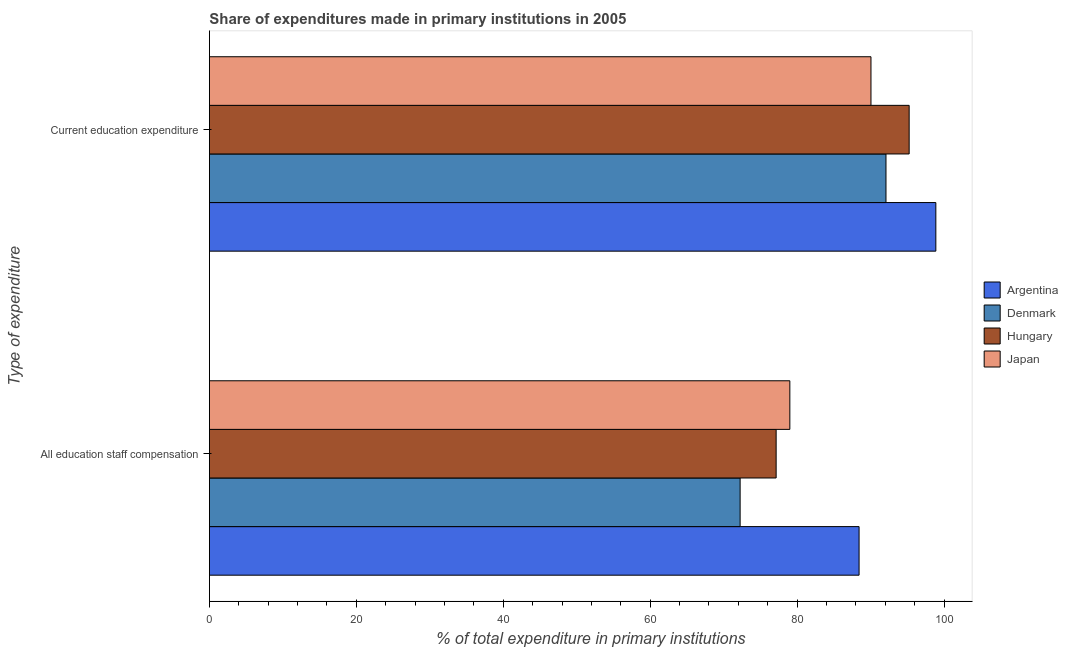How many different coloured bars are there?
Your answer should be very brief. 4. How many groups of bars are there?
Offer a very short reply. 2. Are the number of bars on each tick of the Y-axis equal?
Your answer should be very brief. Yes. How many bars are there on the 2nd tick from the bottom?
Your answer should be compact. 4. What is the label of the 2nd group of bars from the top?
Give a very brief answer. All education staff compensation. What is the expenditure in education in Hungary?
Provide a succinct answer. 95.25. Across all countries, what is the maximum expenditure in staff compensation?
Make the answer very short. 88.43. Across all countries, what is the minimum expenditure in education?
Give a very brief answer. 90.05. What is the total expenditure in education in the graph?
Provide a succinct answer. 376.27. What is the difference between the expenditure in staff compensation in Japan and that in Hungary?
Give a very brief answer. 1.86. What is the difference between the expenditure in staff compensation in Denmark and the expenditure in education in Japan?
Provide a succinct answer. -17.81. What is the average expenditure in education per country?
Offer a terse response. 94.07. What is the difference between the expenditure in education and expenditure in staff compensation in Hungary?
Your answer should be very brief. 18.11. What is the ratio of the expenditure in education in Argentina to that in Denmark?
Provide a short and direct response. 1.07. What does the 2nd bar from the bottom in All education staff compensation represents?
Provide a short and direct response. Denmark. Are all the bars in the graph horizontal?
Keep it short and to the point. Yes. How many countries are there in the graph?
Your answer should be compact. 4. What is the difference between two consecutive major ticks on the X-axis?
Make the answer very short. 20. Does the graph contain any zero values?
Keep it short and to the point. No. Does the graph contain grids?
Your response must be concise. No. How many legend labels are there?
Offer a very short reply. 4. What is the title of the graph?
Your answer should be very brief. Share of expenditures made in primary institutions in 2005. What is the label or title of the X-axis?
Offer a very short reply. % of total expenditure in primary institutions. What is the label or title of the Y-axis?
Keep it short and to the point. Type of expenditure. What is the % of total expenditure in primary institutions in Argentina in All education staff compensation?
Offer a terse response. 88.43. What is the % of total expenditure in primary institutions in Denmark in All education staff compensation?
Give a very brief answer. 72.24. What is the % of total expenditure in primary institutions in Hungary in All education staff compensation?
Offer a very short reply. 77.14. What is the % of total expenditure in primary institutions of Japan in All education staff compensation?
Keep it short and to the point. 79.01. What is the % of total expenditure in primary institutions in Argentina in Current education expenditure?
Give a very brief answer. 98.88. What is the % of total expenditure in primary institutions of Denmark in Current education expenditure?
Offer a terse response. 92.09. What is the % of total expenditure in primary institutions of Hungary in Current education expenditure?
Ensure brevity in your answer.  95.25. What is the % of total expenditure in primary institutions of Japan in Current education expenditure?
Give a very brief answer. 90.05. Across all Type of expenditure, what is the maximum % of total expenditure in primary institutions of Argentina?
Keep it short and to the point. 98.88. Across all Type of expenditure, what is the maximum % of total expenditure in primary institutions of Denmark?
Ensure brevity in your answer.  92.09. Across all Type of expenditure, what is the maximum % of total expenditure in primary institutions in Hungary?
Keep it short and to the point. 95.25. Across all Type of expenditure, what is the maximum % of total expenditure in primary institutions of Japan?
Keep it short and to the point. 90.05. Across all Type of expenditure, what is the minimum % of total expenditure in primary institutions of Argentina?
Your answer should be very brief. 88.43. Across all Type of expenditure, what is the minimum % of total expenditure in primary institutions in Denmark?
Give a very brief answer. 72.24. Across all Type of expenditure, what is the minimum % of total expenditure in primary institutions of Hungary?
Ensure brevity in your answer.  77.14. Across all Type of expenditure, what is the minimum % of total expenditure in primary institutions of Japan?
Keep it short and to the point. 79.01. What is the total % of total expenditure in primary institutions of Argentina in the graph?
Offer a very short reply. 187.31. What is the total % of total expenditure in primary institutions in Denmark in the graph?
Make the answer very short. 164.33. What is the total % of total expenditure in primary institutions in Hungary in the graph?
Provide a succinct answer. 172.39. What is the total % of total expenditure in primary institutions in Japan in the graph?
Your answer should be very brief. 169.05. What is the difference between the % of total expenditure in primary institutions in Argentina in All education staff compensation and that in Current education expenditure?
Give a very brief answer. -10.45. What is the difference between the % of total expenditure in primary institutions in Denmark in All education staff compensation and that in Current education expenditure?
Offer a terse response. -19.85. What is the difference between the % of total expenditure in primary institutions of Hungary in All education staff compensation and that in Current education expenditure?
Provide a short and direct response. -18.11. What is the difference between the % of total expenditure in primary institutions of Japan in All education staff compensation and that in Current education expenditure?
Your answer should be very brief. -11.04. What is the difference between the % of total expenditure in primary institutions in Argentina in All education staff compensation and the % of total expenditure in primary institutions in Denmark in Current education expenditure?
Your response must be concise. -3.66. What is the difference between the % of total expenditure in primary institutions in Argentina in All education staff compensation and the % of total expenditure in primary institutions in Hungary in Current education expenditure?
Give a very brief answer. -6.82. What is the difference between the % of total expenditure in primary institutions in Argentina in All education staff compensation and the % of total expenditure in primary institutions in Japan in Current education expenditure?
Provide a succinct answer. -1.62. What is the difference between the % of total expenditure in primary institutions of Denmark in All education staff compensation and the % of total expenditure in primary institutions of Hungary in Current education expenditure?
Ensure brevity in your answer.  -23.01. What is the difference between the % of total expenditure in primary institutions in Denmark in All education staff compensation and the % of total expenditure in primary institutions in Japan in Current education expenditure?
Ensure brevity in your answer.  -17.81. What is the difference between the % of total expenditure in primary institutions of Hungary in All education staff compensation and the % of total expenditure in primary institutions of Japan in Current education expenditure?
Your response must be concise. -12.91. What is the average % of total expenditure in primary institutions in Argentina per Type of expenditure?
Keep it short and to the point. 93.65. What is the average % of total expenditure in primary institutions of Denmark per Type of expenditure?
Offer a terse response. 82.17. What is the average % of total expenditure in primary institutions of Hungary per Type of expenditure?
Give a very brief answer. 86.19. What is the average % of total expenditure in primary institutions in Japan per Type of expenditure?
Keep it short and to the point. 84.53. What is the difference between the % of total expenditure in primary institutions in Argentina and % of total expenditure in primary institutions in Denmark in All education staff compensation?
Make the answer very short. 16.19. What is the difference between the % of total expenditure in primary institutions in Argentina and % of total expenditure in primary institutions in Hungary in All education staff compensation?
Your answer should be very brief. 11.29. What is the difference between the % of total expenditure in primary institutions in Argentina and % of total expenditure in primary institutions in Japan in All education staff compensation?
Make the answer very short. 9.43. What is the difference between the % of total expenditure in primary institutions in Denmark and % of total expenditure in primary institutions in Hungary in All education staff compensation?
Give a very brief answer. -4.9. What is the difference between the % of total expenditure in primary institutions of Denmark and % of total expenditure in primary institutions of Japan in All education staff compensation?
Your answer should be compact. -6.77. What is the difference between the % of total expenditure in primary institutions of Hungary and % of total expenditure in primary institutions of Japan in All education staff compensation?
Keep it short and to the point. -1.86. What is the difference between the % of total expenditure in primary institutions of Argentina and % of total expenditure in primary institutions of Denmark in Current education expenditure?
Ensure brevity in your answer.  6.79. What is the difference between the % of total expenditure in primary institutions of Argentina and % of total expenditure in primary institutions of Hungary in Current education expenditure?
Your answer should be very brief. 3.63. What is the difference between the % of total expenditure in primary institutions of Argentina and % of total expenditure in primary institutions of Japan in Current education expenditure?
Your answer should be compact. 8.83. What is the difference between the % of total expenditure in primary institutions of Denmark and % of total expenditure in primary institutions of Hungary in Current education expenditure?
Offer a very short reply. -3.16. What is the difference between the % of total expenditure in primary institutions of Denmark and % of total expenditure in primary institutions of Japan in Current education expenditure?
Provide a short and direct response. 2.04. What is the difference between the % of total expenditure in primary institutions of Hungary and % of total expenditure in primary institutions of Japan in Current education expenditure?
Give a very brief answer. 5.2. What is the ratio of the % of total expenditure in primary institutions in Argentina in All education staff compensation to that in Current education expenditure?
Your answer should be very brief. 0.89. What is the ratio of the % of total expenditure in primary institutions of Denmark in All education staff compensation to that in Current education expenditure?
Your response must be concise. 0.78. What is the ratio of the % of total expenditure in primary institutions of Hungary in All education staff compensation to that in Current education expenditure?
Give a very brief answer. 0.81. What is the ratio of the % of total expenditure in primary institutions of Japan in All education staff compensation to that in Current education expenditure?
Offer a very short reply. 0.88. What is the difference between the highest and the second highest % of total expenditure in primary institutions of Argentina?
Give a very brief answer. 10.45. What is the difference between the highest and the second highest % of total expenditure in primary institutions in Denmark?
Offer a terse response. 19.85. What is the difference between the highest and the second highest % of total expenditure in primary institutions in Hungary?
Your answer should be very brief. 18.11. What is the difference between the highest and the second highest % of total expenditure in primary institutions of Japan?
Ensure brevity in your answer.  11.04. What is the difference between the highest and the lowest % of total expenditure in primary institutions of Argentina?
Provide a short and direct response. 10.45. What is the difference between the highest and the lowest % of total expenditure in primary institutions of Denmark?
Provide a succinct answer. 19.85. What is the difference between the highest and the lowest % of total expenditure in primary institutions of Hungary?
Make the answer very short. 18.11. What is the difference between the highest and the lowest % of total expenditure in primary institutions of Japan?
Keep it short and to the point. 11.04. 